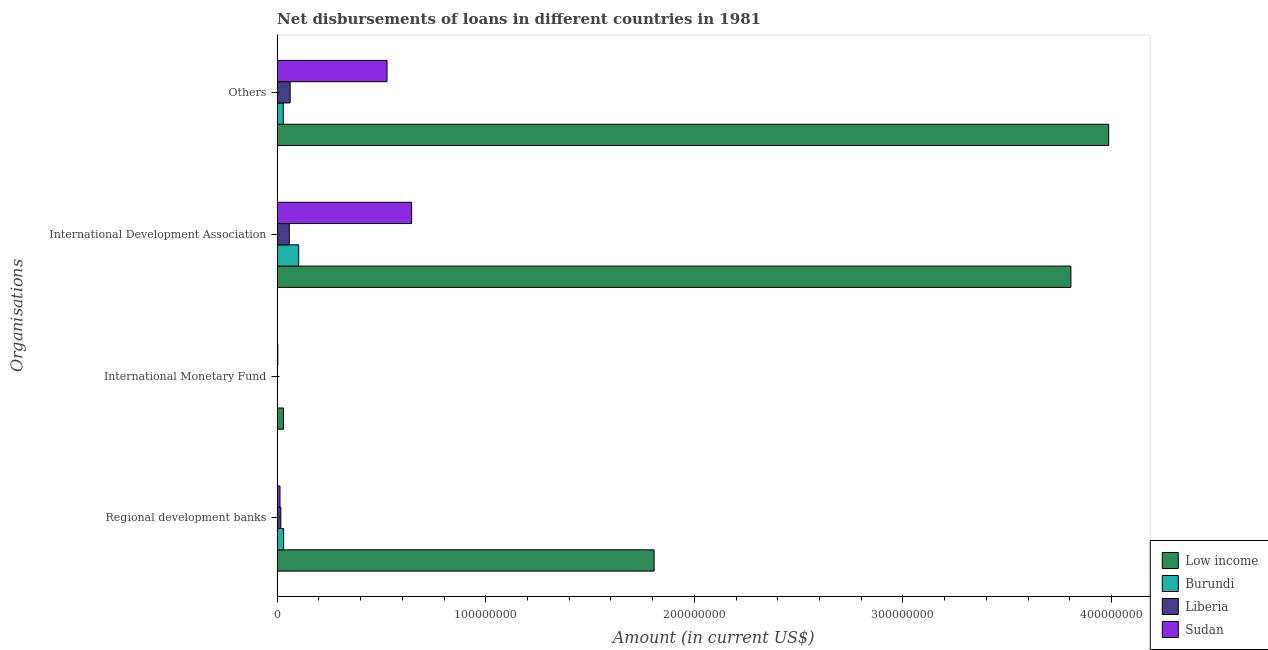How many different coloured bars are there?
Offer a very short reply. 4. How many groups of bars are there?
Give a very brief answer. 4. Are the number of bars per tick equal to the number of legend labels?
Offer a terse response. Yes. Are the number of bars on each tick of the Y-axis equal?
Provide a short and direct response. Yes. How many bars are there on the 2nd tick from the top?
Give a very brief answer. 4. How many bars are there on the 1st tick from the bottom?
Make the answer very short. 4. What is the label of the 3rd group of bars from the top?
Provide a succinct answer. International Monetary Fund. What is the amount of loan disimbursed by international development association in Low income?
Ensure brevity in your answer.  3.81e+08. Across all countries, what is the maximum amount of loan disimbursed by international development association?
Keep it short and to the point. 3.81e+08. Across all countries, what is the minimum amount of loan disimbursed by international monetary fund?
Offer a very short reply. 8.50e+04. In which country was the amount of loan disimbursed by international development association maximum?
Keep it short and to the point. Low income. In which country was the amount of loan disimbursed by international monetary fund minimum?
Your response must be concise. Burundi. What is the total amount of loan disimbursed by international monetary fund in the graph?
Your answer should be very brief. 3.55e+06. What is the difference between the amount of loan disimbursed by international monetary fund in Sudan and that in Low income?
Your answer should be very brief. -2.70e+06. What is the difference between the amount of loan disimbursed by regional development banks in Sudan and the amount of loan disimbursed by international monetary fund in Low income?
Offer a very short reply. -1.64e+06. What is the average amount of loan disimbursed by regional development banks per country?
Give a very brief answer. 4.67e+07. What is the difference between the amount of loan disimbursed by international monetary fund and amount of loan disimbursed by regional development banks in Low income?
Provide a succinct answer. -1.78e+08. In how many countries, is the amount of loan disimbursed by international monetary fund greater than 360000000 US$?
Provide a succinct answer. 0. What is the ratio of the amount of loan disimbursed by regional development banks in Sudan to that in Liberia?
Make the answer very short. 0.78. What is the difference between the highest and the second highest amount of loan disimbursed by other organisations?
Provide a succinct answer. 3.46e+08. What is the difference between the highest and the lowest amount of loan disimbursed by other organisations?
Provide a short and direct response. 3.96e+08. In how many countries, is the amount of loan disimbursed by international monetary fund greater than the average amount of loan disimbursed by international monetary fund taken over all countries?
Give a very brief answer. 1. Is it the case that in every country, the sum of the amount of loan disimbursed by other organisations and amount of loan disimbursed by international monetary fund is greater than the sum of amount of loan disimbursed by international development association and amount of loan disimbursed by regional development banks?
Provide a short and direct response. No. What does the 3rd bar from the top in Regional development banks represents?
Provide a short and direct response. Burundi. Are all the bars in the graph horizontal?
Your response must be concise. Yes. How many countries are there in the graph?
Ensure brevity in your answer.  4. Are the values on the major ticks of X-axis written in scientific E-notation?
Your answer should be very brief. No. Does the graph contain grids?
Your answer should be very brief. No. Where does the legend appear in the graph?
Your answer should be compact. Bottom right. How many legend labels are there?
Your answer should be very brief. 4. How are the legend labels stacked?
Make the answer very short. Vertical. What is the title of the graph?
Your response must be concise. Net disbursements of loans in different countries in 1981. Does "Northern Mariana Islands" appear as one of the legend labels in the graph?
Your answer should be compact. No. What is the label or title of the Y-axis?
Give a very brief answer. Organisations. What is the Amount (in current US$) in Low income in Regional development banks?
Provide a succinct answer. 1.81e+08. What is the Amount (in current US$) in Burundi in Regional development banks?
Provide a succinct answer. 3.11e+06. What is the Amount (in current US$) of Liberia in Regional development banks?
Offer a very short reply. 1.76e+06. What is the Amount (in current US$) in Sudan in Regional development banks?
Provide a short and direct response. 1.37e+06. What is the Amount (in current US$) of Low income in International Monetary Fund?
Keep it short and to the point. 3.02e+06. What is the Amount (in current US$) of Burundi in International Monetary Fund?
Your response must be concise. 8.50e+04. What is the Amount (in current US$) in Liberia in International Monetary Fund?
Provide a short and direct response. 1.29e+05. What is the Amount (in current US$) in Sudan in International Monetary Fund?
Ensure brevity in your answer.  3.20e+05. What is the Amount (in current US$) in Low income in International Development Association?
Provide a succinct answer. 3.81e+08. What is the Amount (in current US$) in Burundi in International Development Association?
Provide a short and direct response. 1.03e+07. What is the Amount (in current US$) in Liberia in International Development Association?
Ensure brevity in your answer.  5.83e+06. What is the Amount (in current US$) in Sudan in International Development Association?
Offer a terse response. 6.45e+07. What is the Amount (in current US$) of Low income in Others?
Provide a succinct answer. 3.99e+08. What is the Amount (in current US$) in Burundi in Others?
Provide a short and direct response. 2.94e+06. What is the Amount (in current US$) of Liberia in Others?
Ensure brevity in your answer.  6.24e+06. What is the Amount (in current US$) in Sudan in Others?
Your response must be concise. 5.27e+07. Across all Organisations, what is the maximum Amount (in current US$) of Low income?
Provide a short and direct response. 3.99e+08. Across all Organisations, what is the maximum Amount (in current US$) in Burundi?
Your answer should be compact. 1.03e+07. Across all Organisations, what is the maximum Amount (in current US$) in Liberia?
Your response must be concise. 6.24e+06. Across all Organisations, what is the maximum Amount (in current US$) in Sudan?
Make the answer very short. 6.45e+07. Across all Organisations, what is the minimum Amount (in current US$) in Low income?
Provide a short and direct response. 3.02e+06. Across all Organisations, what is the minimum Amount (in current US$) of Burundi?
Keep it short and to the point. 8.50e+04. Across all Organisations, what is the minimum Amount (in current US$) of Liberia?
Offer a very short reply. 1.29e+05. Across all Organisations, what is the minimum Amount (in current US$) in Sudan?
Give a very brief answer. 3.20e+05. What is the total Amount (in current US$) in Low income in the graph?
Offer a terse response. 9.63e+08. What is the total Amount (in current US$) in Burundi in the graph?
Your response must be concise. 1.65e+07. What is the total Amount (in current US$) in Liberia in the graph?
Your answer should be very brief. 1.40e+07. What is the total Amount (in current US$) of Sudan in the graph?
Offer a terse response. 1.19e+08. What is the difference between the Amount (in current US$) of Low income in Regional development banks and that in International Monetary Fund?
Keep it short and to the point. 1.78e+08. What is the difference between the Amount (in current US$) of Burundi in Regional development banks and that in International Monetary Fund?
Your answer should be very brief. 3.03e+06. What is the difference between the Amount (in current US$) in Liberia in Regional development banks and that in International Monetary Fund?
Offer a very short reply. 1.64e+06. What is the difference between the Amount (in current US$) of Sudan in Regional development banks and that in International Monetary Fund?
Make the answer very short. 1.05e+06. What is the difference between the Amount (in current US$) in Low income in Regional development banks and that in International Development Association?
Ensure brevity in your answer.  -2.00e+08. What is the difference between the Amount (in current US$) of Burundi in Regional development banks and that in International Development Association?
Your response must be concise. -7.23e+06. What is the difference between the Amount (in current US$) of Liberia in Regional development banks and that in International Development Association?
Provide a short and direct response. -4.07e+06. What is the difference between the Amount (in current US$) in Sudan in Regional development banks and that in International Development Association?
Your answer should be very brief. -6.31e+07. What is the difference between the Amount (in current US$) of Low income in Regional development banks and that in Others?
Make the answer very short. -2.18e+08. What is the difference between the Amount (in current US$) in Burundi in Regional development banks and that in Others?
Give a very brief answer. 1.68e+05. What is the difference between the Amount (in current US$) of Liberia in Regional development banks and that in Others?
Make the answer very short. -4.47e+06. What is the difference between the Amount (in current US$) in Sudan in Regional development banks and that in Others?
Offer a terse response. -5.13e+07. What is the difference between the Amount (in current US$) of Low income in International Monetary Fund and that in International Development Association?
Keep it short and to the point. -3.78e+08. What is the difference between the Amount (in current US$) in Burundi in International Monetary Fund and that in International Development Association?
Provide a succinct answer. -1.03e+07. What is the difference between the Amount (in current US$) in Liberia in International Monetary Fund and that in International Development Association?
Provide a short and direct response. -5.70e+06. What is the difference between the Amount (in current US$) in Sudan in International Monetary Fund and that in International Development Association?
Provide a short and direct response. -6.42e+07. What is the difference between the Amount (in current US$) of Low income in International Monetary Fund and that in Others?
Ensure brevity in your answer.  -3.96e+08. What is the difference between the Amount (in current US$) in Burundi in International Monetary Fund and that in Others?
Your answer should be very brief. -2.86e+06. What is the difference between the Amount (in current US$) in Liberia in International Monetary Fund and that in Others?
Make the answer very short. -6.11e+06. What is the difference between the Amount (in current US$) in Sudan in International Monetary Fund and that in Others?
Provide a short and direct response. -5.24e+07. What is the difference between the Amount (in current US$) in Low income in International Development Association and that in Others?
Give a very brief answer. -1.81e+07. What is the difference between the Amount (in current US$) of Burundi in International Development Association and that in Others?
Offer a terse response. 7.40e+06. What is the difference between the Amount (in current US$) in Liberia in International Development Association and that in Others?
Give a very brief answer. -4.06e+05. What is the difference between the Amount (in current US$) of Sudan in International Development Association and that in Others?
Ensure brevity in your answer.  1.18e+07. What is the difference between the Amount (in current US$) of Low income in Regional development banks and the Amount (in current US$) of Burundi in International Monetary Fund?
Your answer should be compact. 1.81e+08. What is the difference between the Amount (in current US$) in Low income in Regional development banks and the Amount (in current US$) in Liberia in International Monetary Fund?
Your answer should be compact. 1.81e+08. What is the difference between the Amount (in current US$) of Low income in Regional development banks and the Amount (in current US$) of Sudan in International Monetary Fund?
Your answer should be very brief. 1.80e+08. What is the difference between the Amount (in current US$) of Burundi in Regional development banks and the Amount (in current US$) of Liberia in International Monetary Fund?
Offer a terse response. 2.98e+06. What is the difference between the Amount (in current US$) of Burundi in Regional development banks and the Amount (in current US$) of Sudan in International Monetary Fund?
Offer a very short reply. 2.79e+06. What is the difference between the Amount (in current US$) in Liberia in Regional development banks and the Amount (in current US$) in Sudan in International Monetary Fund?
Provide a short and direct response. 1.44e+06. What is the difference between the Amount (in current US$) in Low income in Regional development banks and the Amount (in current US$) in Burundi in International Development Association?
Ensure brevity in your answer.  1.70e+08. What is the difference between the Amount (in current US$) in Low income in Regional development banks and the Amount (in current US$) in Liberia in International Development Association?
Give a very brief answer. 1.75e+08. What is the difference between the Amount (in current US$) of Low income in Regional development banks and the Amount (in current US$) of Sudan in International Development Association?
Keep it short and to the point. 1.16e+08. What is the difference between the Amount (in current US$) in Burundi in Regional development banks and the Amount (in current US$) in Liberia in International Development Association?
Your answer should be very brief. -2.72e+06. What is the difference between the Amount (in current US$) of Burundi in Regional development banks and the Amount (in current US$) of Sudan in International Development Association?
Provide a short and direct response. -6.14e+07. What is the difference between the Amount (in current US$) in Liberia in Regional development banks and the Amount (in current US$) in Sudan in International Development Association?
Ensure brevity in your answer.  -6.27e+07. What is the difference between the Amount (in current US$) in Low income in Regional development banks and the Amount (in current US$) in Burundi in Others?
Your answer should be compact. 1.78e+08. What is the difference between the Amount (in current US$) of Low income in Regional development banks and the Amount (in current US$) of Liberia in Others?
Your answer should be very brief. 1.74e+08. What is the difference between the Amount (in current US$) of Low income in Regional development banks and the Amount (in current US$) of Sudan in Others?
Your response must be concise. 1.28e+08. What is the difference between the Amount (in current US$) in Burundi in Regional development banks and the Amount (in current US$) in Liberia in Others?
Your response must be concise. -3.12e+06. What is the difference between the Amount (in current US$) of Burundi in Regional development banks and the Amount (in current US$) of Sudan in Others?
Your response must be concise. -4.96e+07. What is the difference between the Amount (in current US$) in Liberia in Regional development banks and the Amount (in current US$) in Sudan in Others?
Make the answer very short. -5.09e+07. What is the difference between the Amount (in current US$) of Low income in International Monetary Fund and the Amount (in current US$) of Burundi in International Development Association?
Your answer should be very brief. -7.33e+06. What is the difference between the Amount (in current US$) in Low income in International Monetary Fund and the Amount (in current US$) in Liberia in International Development Association?
Give a very brief answer. -2.81e+06. What is the difference between the Amount (in current US$) in Low income in International Monetary Fund and the Amount (in current US$) in Sudan in International Development Association?
Your answer should be very brief. -6.15e+07. What is the difference between the Amount (in current US$) in Burundi in International Monetary Fund and the Amount (in current US$) in Liberia in International Development Association?
Give a very brief answer. -5.75e+06. What is the difference between the Amount (in current US$) of Burundi in International Monetary Fund and the Amount (in current US$) of Sudan in International Development Association?
Keep it short and to the point. -6.44e+07. What is the difference between the Amount (in current US$) in Liberia in International Monetary Fund and the Amount (in current US$) in Sudan in International Development Association?
Offer a very short reply. -6.44e+07. What is the difference between the Amount (in current US$) of Low income in International Monetary Fund and the Amount (in current US$) of Burundi in Others?
Give a very brief answer. 7.20e+04. What is the difference between the Amount (in current US$) of Low income in International Monetary Fund and the Amount (in current US$) of Liberia in Others?
Give a very brief answer. -3.22e+06. What is the difference between the Amount (in current US$) of Low income in International Monetary Fund and the Amount (in current US$) of Sudan in Others?
Offer a terse response. -4.97e+07. What is the difference between the Amount (in current US$) of Burundi in International Monetary Fund and the Amount (in current US$) of Liberia in Others?
Give a very brief answer. -6.15e+06. What is the difference between the Amount (in current US$) of Burundi in International Monetary Fund and the Amount (in current US$) of Sudan in Others?
Provide a succinct answer. -5.26e+07. What is the difference between the Amount (in current US$) of Liberia in International Monetary Fund and the Amount (in current US$) of Sudan in Others?
Offer a very short reply. -5.26e+07. What is the difference between the Amount (in current US$) of Low income in International Development Association and the Amount (in current US$) of Burundi in Others?
Give a very brief answer. 3.78e+08. What is the difference between the Amount (in current US$) of Low income in International Development Association and the Amount (in current US$) of Liberia in Others?
Your answer should be compact. 3.74e+08. What is the difference between the Amount (in current US$) in Low income in International Development Association and the Amount (in current US$) in Sudan in Others?
Offer a terse response. 3.28e+08. What is the difference between the Amount (in current US$) of Burundi in International Development Association and the Amount (in current US$) of Liberia in Others?
Offer a very short reply. 4.11e+06. What is the difference between the Amount (in current US$) of Burundi in International Development Association and the Amount (in current US$) of Sudan in Others?
Your answer should be very brief. -4.24e+07. What is the difference between the Amount (in current US$) of Liberia in International Development Association and the Amount (in current US$) of Sudan in Others?
Your answer should be compact. -4.69e+07. What is the average Amount (in current US$) of Low income per Organisations?
Offer a very short reply. 2.41e+08. What is the average Amount (in current US$) in Burundi per Organisations?
Your answer should be very brief. 4.12e+06. What is the average Amount (in current US$) in Liberia per Organisations?
Ensure brevity in your answer.  3.49e+06. What is the average Amount (in current US$) of Sudan per Organisations?
Ensure brevity in your answer.  2.97e+07. What is the difference between the Amount (in current US$) of Low income and Amount (in current US$) of Burundi in Regional development banks?
Offer a very short reply. 1.78e+08. What is the difference between the Amount (in current US$) in Low income and Amount (in current US$) in Liberia in Regional development banks?
Provide a succinct answer. 1.79e+08. What is the difference between the Amount (in current US$) of Low income and Amount (in current US$) of Sudan in Regional development banks?
Give a very brief answer. 1.79e+08. What is the difference between the Amount (in current US$) of Burundi and Amount (in current US$) of Liberia in Regional development banks?
Your answer should be very brief. 1.35e+06. What is the difference between the Amount (in current US$) of Burundi and Amount (in current US$) of Sudan in Regional development banks?
Make the answer very short. 1.74e+06. What is the difference between the Amount (in current US$) of Liberia and Amount (in current US$) of Sudan in Regional development banks?
Make the answer very short. 3.92e+05. What is the difference between the Amount (in current US$) of Low income and Amount (in current US$) of Burundi in International Monetary Fund?
Your answer should be compact. 2.93e+06. What is the difference between the Amount (in current US$) in Low income and Amount (in current US$) in Liberia in International Monetary Fund?
Keep it short and to the point. 2.89e+06. What is the difference between the Amount (in current US$) in Low income and Amount (in current US$) in Sudan in International Monetary Fund?
Your response must be concise. 2.70e+06. What is the difference between the Amount (in current US$) in Burundi and Amount (in current US$) in Liberia in International Monetary Fund?
Your response must be concise. -4.40e+04. What is the difference between the Amount (in current US$) in Burundi and Amount (in current US$) in Sudan in International Monetary Fund?
Your answer should be compact. -2.35e+05. What is the difference between the Amount (in current US$) in Liberia and Amount (in current US$) in Sudan in International Monetary Fund?
Offer a terse response. -1.91e+05. What is the difference between the Amount (in current US$) in Low income and Amount (in current US$) in Burundi in International Development Association?
Make the answer very short. 3.70e+08. What is the difference between the Amount (in current US$) of Low income and Amount (in current US$) of Liberia in International Development Association?
Your answer should be compact. 3.75e+08. What is the difference between the Amount (in current US$) of Low income and Amount (in current US$) of Sudan in International Development Association?
Provide a succinct answer. 3.16e+08. What is the difference between the Amount (in current US$) of Burundi and Amount (in current US$) of Liberia in International Development Association?
Your response must be concise. 4.52e+06. What is the difference between the Amount (in current US$) of Burundi and Amount (in current US$) of Sudan in International Development Association?
Give a very brief answer. -5.41e+07. What is the difference between the Amount (in current US$) in Liberia and Amount (in current US$) in Sudan in International Development Association?
Your answer should be compact. -5.86e+07. What is the difference between the Amount (in current US$) of Low income and Amount (in current US$) of Burundi in Others?
Your answer should be compact. 3.96e+08. What is the difference between the Amount (in current US$) in Low income and Amount (in current US$) in Liberia in Others?
Provide a short and direct response. 3.92e+08. What is the difference between the Amount (in current US$) of Low income and Amount (in current US$) of Sudan in Others?
Provide a short and direct response. 3.46e+08. What is the difference between the Amount (in current US$) in Burundi and Amount (in current US$) in Liberia in Others?
Offer a very short reply. -3.29e+06. What is the difference between the Amount (in current US$) in Burundi and Amount (in current US$) in Sudan in Others?
Ensure brevity in your answer.  -4.98e+07. What is the difference between the Amount (in current US$) of Liberia and Amount (in current US$) of Sudan in Others?
Give a very brief answer. -4.65e+07. What is the ratio of the Amount (in current US$) of Low income in Regional development banks to that in International Monetary Fund?
Offer a terse response. 59.91. What is the ratio of the Amount (in current US$) in Burundi in Regional development banks to that in International Monetary Fund?
Offer a terse response. 36.62. What is the ratio of the Amount (in current US$) in Liberia in Regional development banks to that in International Monetary Fund?
Your response must be concise. 13.67. What is the ratio of the Amount (in current US$) of Sudan in Regional development banks to that in International Monetary Fund?
Provide a succinct answer. 4.29. What is the ratio of the Amount (in current US$) in Low income in Regional development banks to that in International Development Association?
Give a very brief answer. 0.47. What is the ratio of the Amount (in current US$) of Burundi in Regional development banks to that in International Development Association?
Give a very brief answer. 0.3. What is the ratio of the Amount (in current US$) in Liberia in Regional development banks to that in International Development Association?
Keep it short and to the point. 0.3. What is the ratio of the Amount (in current US$) of Sudan in Regional development banks to that in International Development Association?
Keep it short and to the point. 0.02. What is the ratio of the Amount (in current US$) of Low income in Regional development banks to that in Others?
Provide a succinct answer. 0.45. What is the ratio of the Amount (in current US$) of Burundi in Regional development banks to that in Others?
Give a very brief answer. 1.06. What is the ratio of the Amount (in current US$) in Liberia in Regional development banks to that in Others?
Keep it short and to the point. 0.28. What is the ratio of the Amount (in current US$) in Sudan in Regional development banks to that in Others?
Provide a succinct answer. 0.03. What is the ratio of the Amount (in current US$) in Low income in International Monetary Fund to that in International Development Association?
Offer a terse response. 0.01. What is the ratio of the Amount (in current US$) in Burundi in International Monetary Fund to that in International Development Association?
Provide a short and direct response. 0.01. What is the ratio of the Amount (in current US$) in Liberia in International Monetary Fund to that in International Development Association?
Your response must be concise. 0.02. What is the ratio of the Amount (in current US$) of Sudan in International Monetary Fund to that in International Development Association?
Offer a very short reply. 0.01. What is the ratio of the Amount (in current US$) of Low income in International Monetary Fund to that in Others?
Give a very brief answer. 0.01. What is the ratio of the Amount (in current US$) in Burundi in International Monetary Fund to that in Others?
Provide a succinct answer. 0.03. What is the ratio of the Amount (in current US$) in Liberia in International Monetary Fund to that in Others?
Give a very brief answer. 0.02. What is the ratio of the Amount (in current US$) in Sudan in International Monetary Fund to that in Others?
Provide a short and direct response. 0.01. What is the ratio of the Amount (in current US$) in Low income in International Development Association to that in Others?
Provide a short and direct response. 0.95. What is the ratio of the Amount (in current US$) in Burundi in International Development Association to that in Others?
Provide a succinct answer. 3.51. What is the ratio of the Amount (in current US$) in Liberia in International Development Association to that in Others?
Your response must be concise. 0.93. What is the ratio of the Amount (in current US$) in Sudan in International Development Association to that in Others?
Offer a very short reply. 1.22. What is the difference between the highest and the second highest Amount (in current US$) in Low income?
Ensure brevity in your answer.  1.81e+07. What is the difference between the highest and the second highest Amount (in current US$) of Burundi?
Provide a succinct answer. 7.23e+06. What is the difference between the highest and the second highest Amount (in current US$) of Liberia?
Ensure brevity in your answer.  4.06e+05. What is the difference between the highest and the second highest Amount (in current US$) in Sudan?
Ensure brevity in your answer.  1.18e+07. What is the difference between the highest and the lowest Amount (in current US$) of Low income?
Offer a very short reply. 3.96e+08. What is the difference between the highest and the lowest Amount (in current US$) of Burundi?
Keep it short and to the point. 1.03e+07. What is the difference between the highest and the lowest Amount (in current US$) of Liberia?
Provide a succinct answer. 6.11e+06. What is the difference between the highest and the lowest Amount (in current US$) in Sudan?
Your answer should be compact. 6.42e+07. 